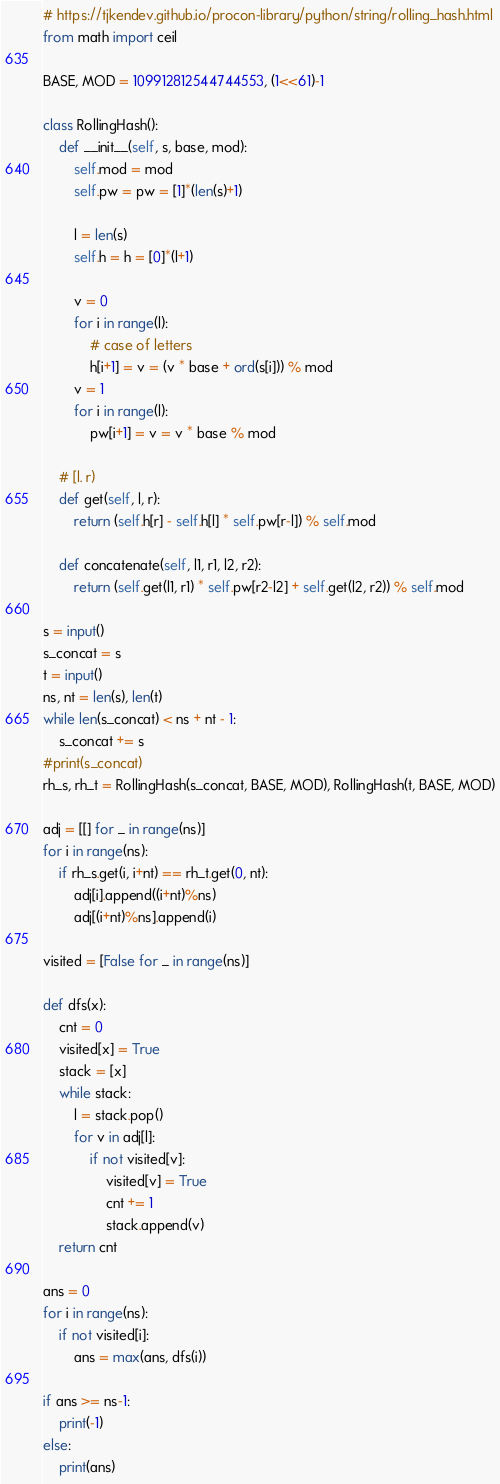Convert code to text. <code><loc_0><loc_0><loc_500><loc_500><_Python_># https://tjkendev.github.io/procon-library/python/string/rolling_hash.html
from math import ceil

BASE, MOD = 109912812544744553, (1<<61)-1

class RollingHash():
	def __init__(self, s, base, mod):
		self.mod = mod
		self.pw = pw = [1]*(len(s)+1)

		l = len(s)
		self.h = h = [0]*(l+1)

		v = 0
		for i in range(l):
			# case of letters
			h[i+1] = v = (v * base + ord(s[i])) % mod
		v = 1
		for i in range(l):
			pw[i+1] = v = v * base % mod

	# [l. r)
	def get(self, l, r):
		return (self.h[r] - self.h[l] * self.pw[r-l]) % self.mod

	def concatenate(self, l1, r1, l2, r2):
		return (self.get(l1, r1) * self.pw[r2-l2] + self.get(l2, r2)) % self.mod

s = input()
s_concat = s
t = input()
ns, nt = len(s), len(t)
while len(s_concat) < ns + nt - 1:
	s_concat += s
#print(s_concat)
rh_s, rh_t = RollingHash(s_concat, BASE, MOD), RollingHash(t, BASE, MOD)

adj = [[] for _ in range(ns)]
for i in range(ns):
	if rh_s.get(i, i+nt) == rh_t.get(0, nt):
		adj[i].append((i+nt)%ns)
		adj[(i+nt)%ns].append(i)

visited = [False for _ in range(ns)]

def dfs(x):
	cnt = 0
	visited[x] = True
	stack = [x]
	while stack:
		l = stack.pop()
		for v in adj[l]:
			if not visited[v]:
				visited[v] = True
				cnt += 1
				stack.append(v)
	return cnt

ans = 0
for i in range(ns):
	if not visited[i]:
		ans = max(ans, dfs(i))

if ans >= ns-1:
	print(-1)
else:
	print(ans)</code> 